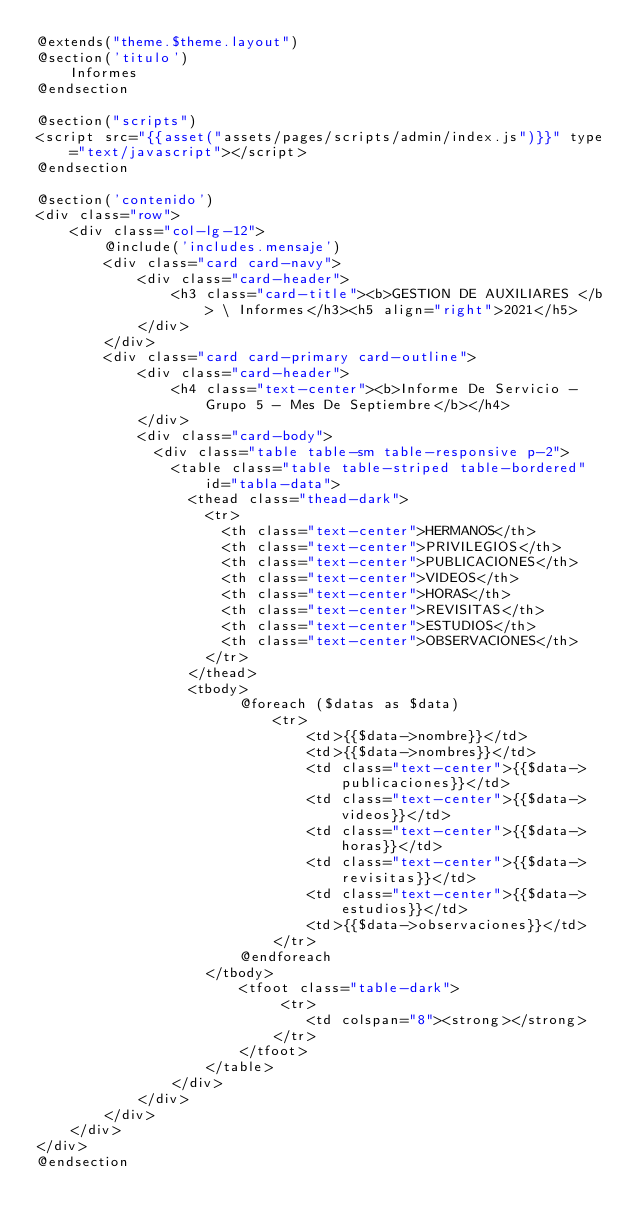Convert code to text. <code><loc_0><loc_0><loc_500><loc_500><_PHP_>@extends("theme.$theme.layout")
@section('titulo')
    Informes
@endsection

@section("scripts")
<script src="{{asset("assets/pages/scripts/admin/index.js")}}" type="text/javascript"></script>
@endsection

@section('contenido')
<div class="row">
    <div class="col-lg-12">
        @include('includes.mensaje')        
        <div class="card card-navy">
            <div class="card-header">
                <h3 class="card-title"><b>GESTION DE AUXILIARES </b> \ Informes</h3><h5 align="right">2021</h5>
            </div>
        </div>
        <div class="card card-primary card-outline">
            <div class="card-header">
                <h4 class="text-center"><b>Informe De Servicio - Grupo 5 - Mes De Septiembre</b></h4>
            </div>
            <div class="card-body"> 
              <div class="table table-sm table-responsive p-2">
                <table class="table table-striped table-bordered" id="tabla-data">
                  <thead class="thead-dark">                  
                    <tr>
                      <th class="text-center">HERMANOS</th>
                      <th class="text-center">PRIVILEGIOS</th>
                      <th class="text-center">PUBLICACIONES</th>
                      <th class="text-center">VIDEOS</th>
                      <th class="text-center">HORAS</th>
                      <th class="text-center">REVISITAS</th>
                      <th class="text-center">ESTUDIOS</th>
                      <th class="text-center">OBSERVACIONES</th>
                    </tr>
                  </thead>
                  <tbody>
                        @foreach ($datas as $data) 
                            <tr>
                                <td>{{$data->nombre}}</td>
                                <td>{{$data->nombres}}</td>                                                                            
                                <td class="text-center">{{$data->publicaciones}}</td>
                                <td class="text-center">{{$data->videos}}</td>
                                <td class="text-center">{{$data->horas}}</td>
                                <td class="text-center">{{$data->revisitas}}</td>
                                <td class="text-center">{{$data->estudios}}</td>
                                <td>{{$data->observaciones}}</td>
                            </tr> 
                        @endforeach     
                    </tbody>
                        <tfoot class="table-dark">
                             <tr>
                                <td colspan="8"><strong></strong>
                            </tr>                       
                        </tfoot>
                    </table>
                </div>
            </div>       
        </div>
    </div>
</div>
@endsection
</code> 